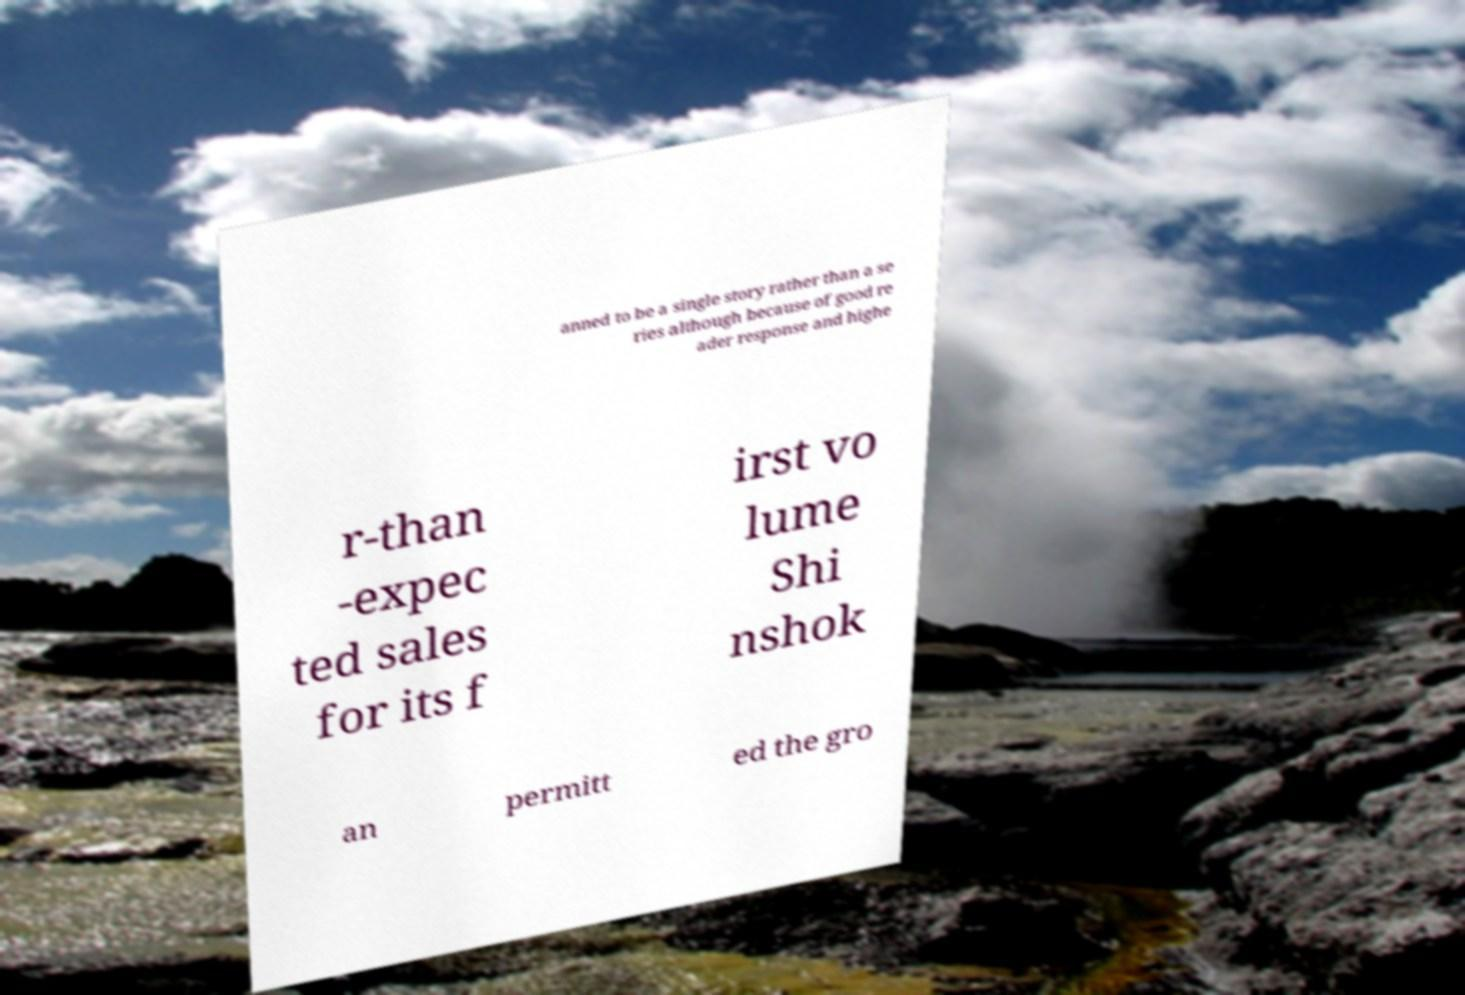Can you accurately transcribe the text from the provided image for me? anned to be a single story rather than a se ries although because of good re ader response and highe r-than -expec ted sales for its f irst vo lume Shi nshok an permitt ed the gro 